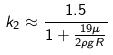<formula> <loc_0><loc_0><loc_500><loc_500>k _ { 2 } \approx \frac { 1 . 5 } { 1 + \frac { 1 9 \mu } { 2 \rho g R } }</formula> 